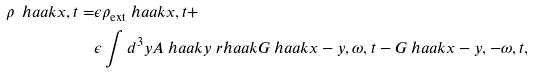Convert formula to latex. <formula><loc_0><loc_0><loc_500><loc_500>\rho \ h a a k { x , t } = & \epsilon \rho _ { \text {ext} } \ h a a k { x , t } + \\ & \epsilon \int d ^ { 3 } y A \ h a a k { y } \ r h a a k { G \ h a a k { x - y , \omega , t } - G \ h a a k { x - y , - \omega , t } } ,</formula> 